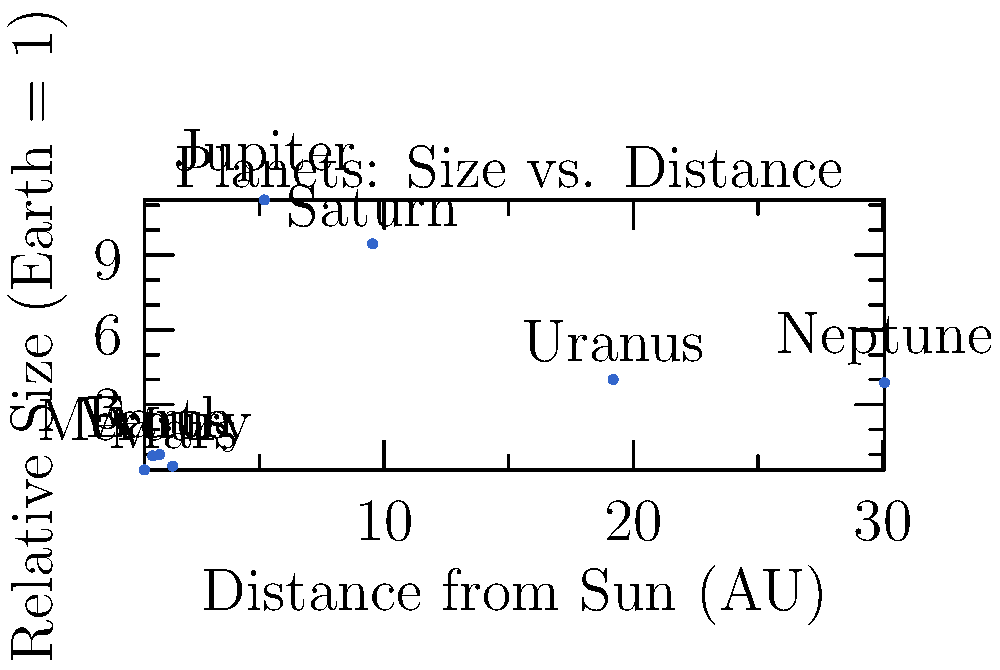In the context of our solar system's structure, which planet deviates most significantly from the general trend of planet size relative to its distance from the Sun, and how might this anomaly relate to the formation of the solar system? To answer this question, we need to analyze the graph and follow these steps:

1. Observe the general trend: As we move farther from the Sun (left to right on the x-axis), planet sizes tend to increase.

2. Identify exceptions:
   a) The gas giants (Jupiter, Saturn, Uranus, Neptune) are significantly larger than the terrestrial planets.
   b) Mars is smaller than Earth and Venus, despite being farther from the Sun.

3. Determine the most significant deviation:
   Jupiter stands out as the largest planet, despite not being the farthest from the Sun. Its size (11.21 Earth radii) is disproportionately large compared to its distance (5.20 AU).

4. Consider the implications for solar system formation:
   Jupiter's anomalous size suggests it played a crucial role in the early solar system's development. Its large mass likely influenced the formation and orbits of other planets, particularly in the inner solar system.

5. Historical context:
   The discovery of Jupiter's size and its implications have been significant in developing our understanding of planetary formation theories, particularly the idea of planetary migration and the "Grand Tack" hypothesis.
Answer: Jupiter, due to its disproportionately large size relative to its distance from the Sun, suggesting a key role in early solar system formation. 